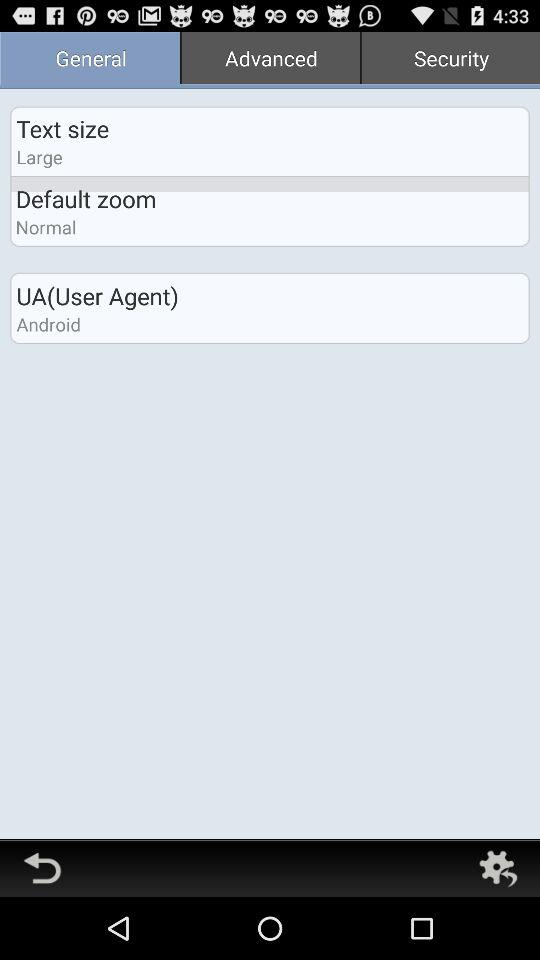What is the user agent? The user agent is "Android". 